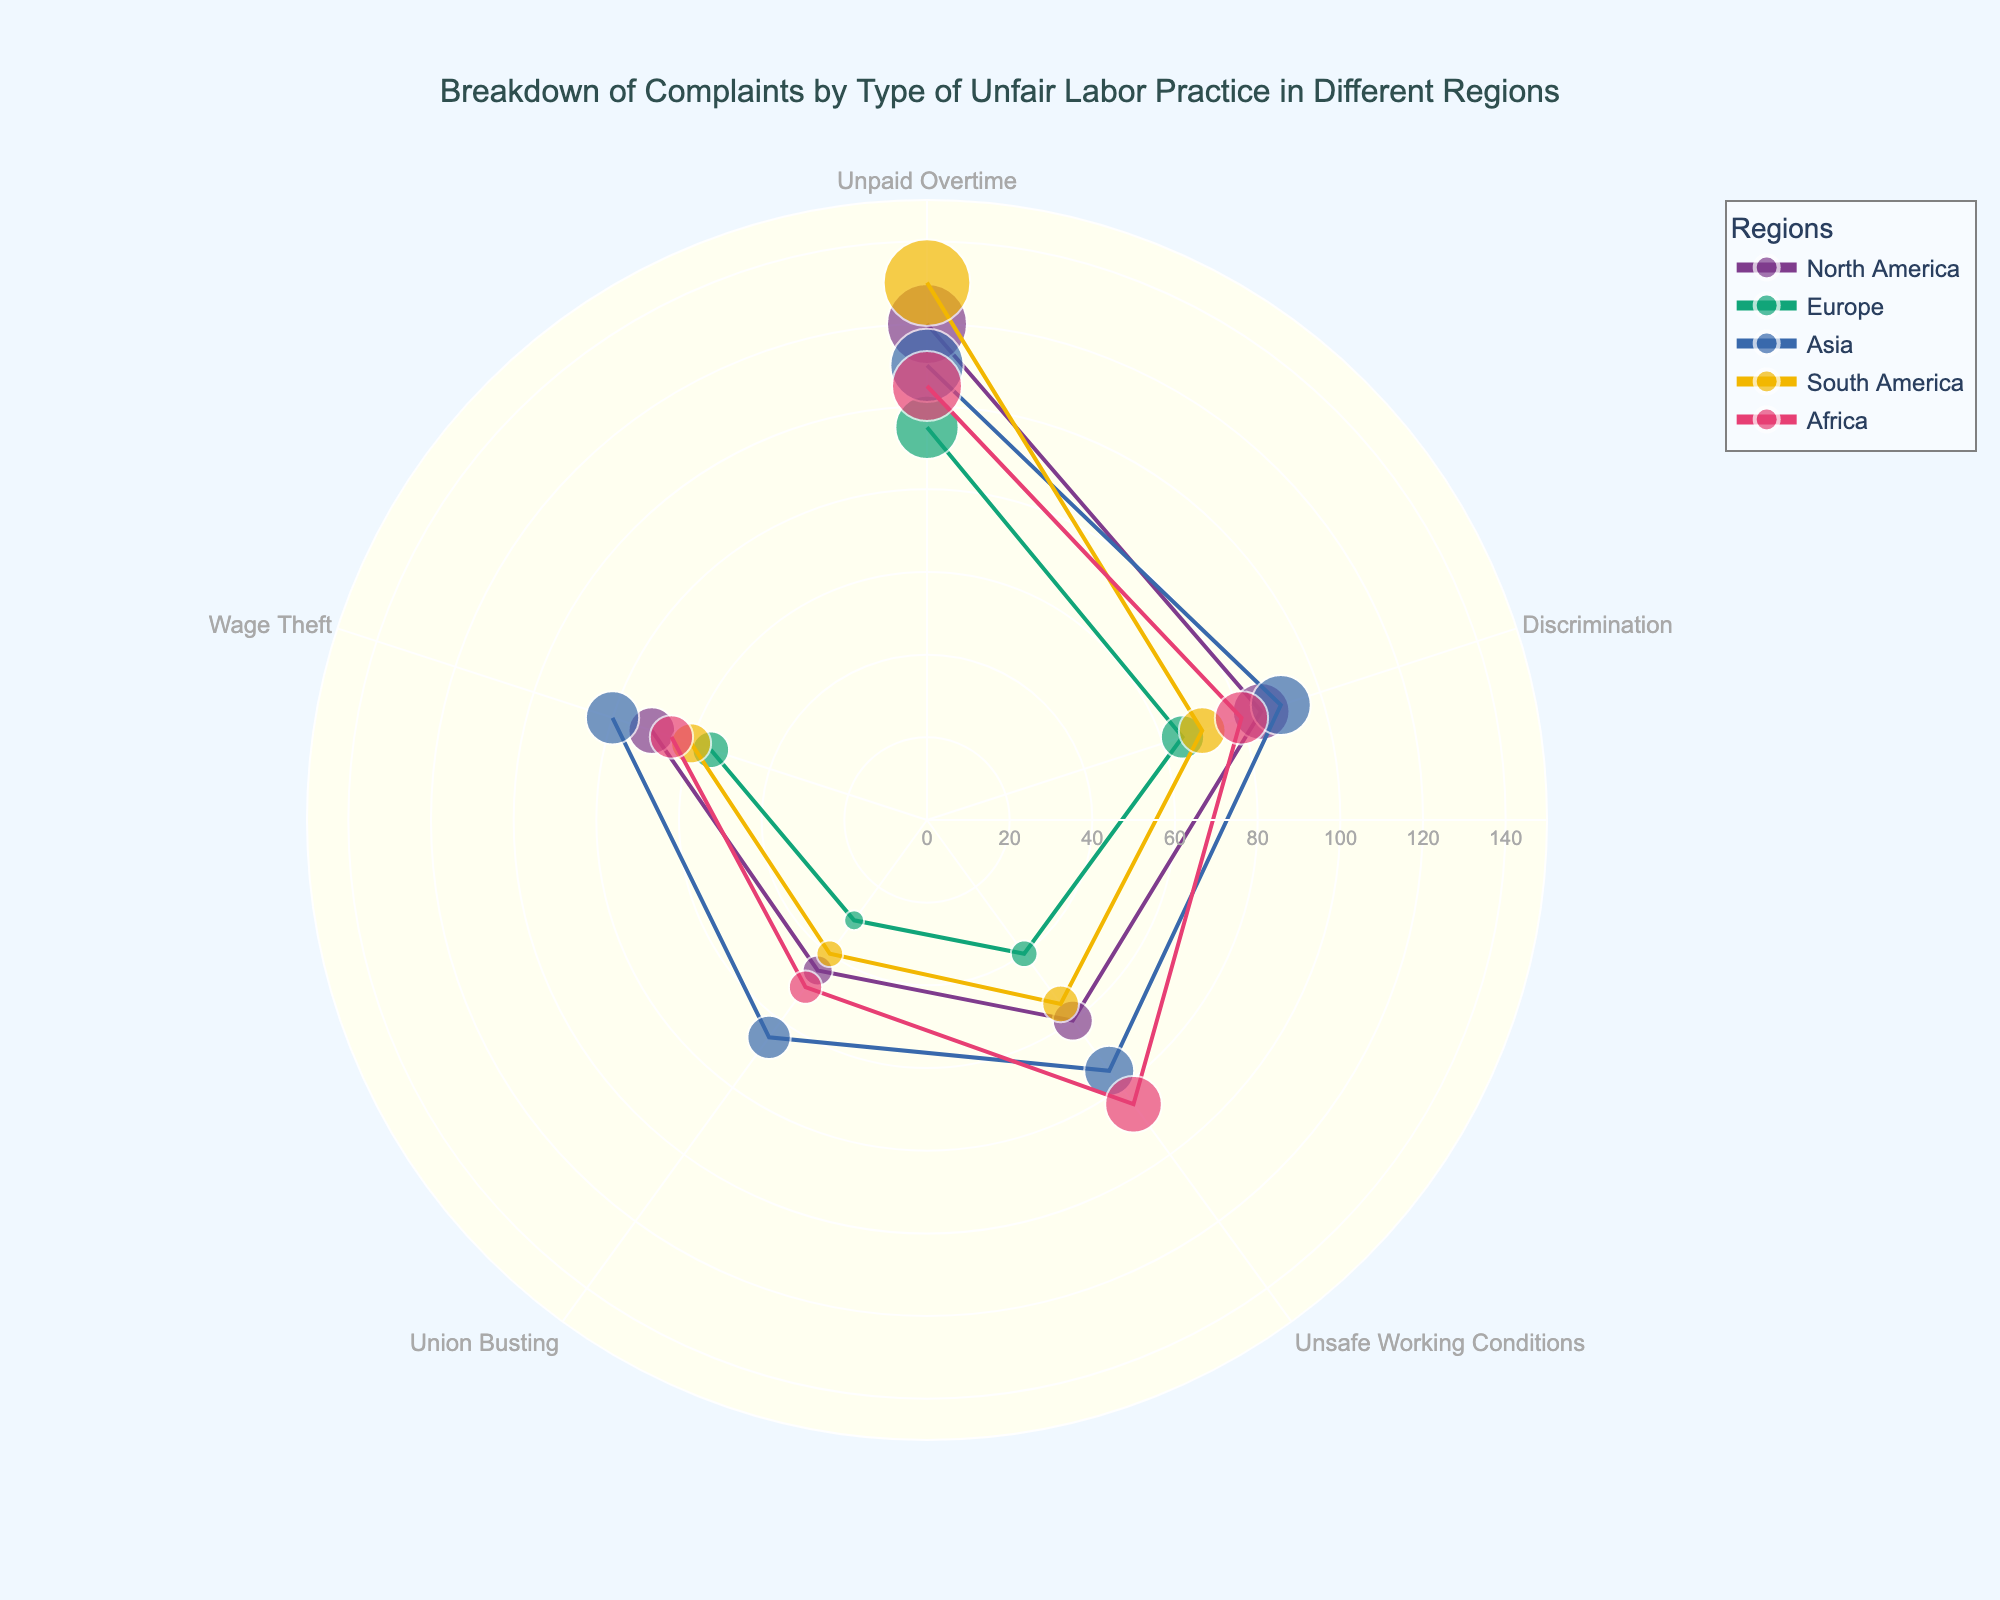How many types of unfair labor practices are shown in the figure? The figure shows complaints for multiple types of unfair labor practices such as Unpaid Overtime, Discrimination, Unsafe Working Conditions, Union Busting, and Wage Theft. By counting these distinct types, we note there are five categories.
Answer: 5 Which region has the highest number of complaints for Unpaid Overtime? Looking at the Unpaid Overtime data points for each region on the polar scatter chart, the data point for South America is the highest.
Answer: South America What is the total number of complaints in Asia? From the chart, we sum the complaints in Asia: Unpaid Overtime (110), Discrimination (90), Unsafe Working Conditions (75), Union Busting (65), and Wage Theft (80). 110 + 90 + 75 + 65 + 80 = 420.
Answer: 420 Which unfair labor practice has the most complaints across all regions? The chart shows different complaints for each unfair labor practice across regions. By comparing the values, Unpaid Overtime consistently appears as the highest number of complaints in all regions.
Answer: Unpaid Overtime How does the number of complaints for Unsafe Working Conditions in Africa compare to Asia? Looking at the data points for Unsafe Working Conditions, Africa has 85 complaints while Asia has 75 complaints. Africa has more complaints than Asia.
Answer: Africa What is the average number of complaints for Union Busting across all regions? We sum the Union Busting complaints for all regions: North America (45), Europe (30), Asia (65), South America (40), and Africa (50). Total is 45 + 30 + 65 + 40 + 50 = 230. Then, we divide by the number of regions (5). 230 / 5 = 46.
Answer: 46 Which region has the least number of total complaints? Summing complaints for each region: North America (120 + 85 + 60 + 45 + 70 = 380), Europe (95 + 65 + 40 + 30 + 55 = 285), Asia (110 + 90 + 75 + 65 + 80 = 420), South America (130 + 70 + 55 + 40 + 60 = 355), and Africa (105 + 80 + 85 + 50 + 65 = 385). Europe has the least number of total complaints (285).
Answer: Europe Is the number of complaints about Discrimination greater in Asia or North America? Comparing data points for Discrimination, Asia has 90 complaints whereas North America has 85 complaints. Asia has more complaints than North America.
Answer: Asia What is the range of complaints for Wage Theft? The lowest number of complaints for Wage Theft is 55 (Europe), and the highest is 80 (Asia). The range is 80 - 55 = 25.
Answer: 25 How does the overall trend in Unpaid Overtime complaints vary across different regions? By observing the complaints for Unpaid Overtime, we see high numbers in all regions with South America (130) being the highest and Europe (95) being the lowest. This indicates that Unpaid Overtime is a significant issue across all regions but varies slightly in magnitude.
Answer: Significant issue across all regions, highest in South America, lowest in Europe 